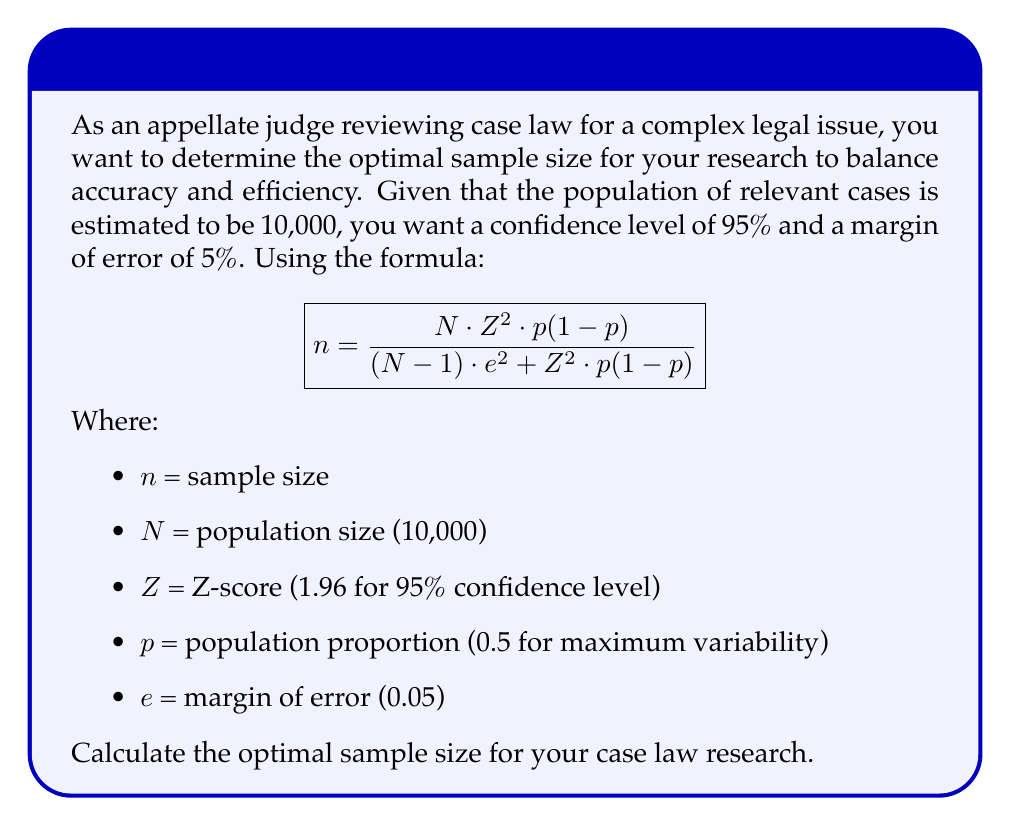What is the answer to this math problem? To solve this problem, we'll substitute the given values into the formula:

1) $N = 10,000$ (population size)
2) $Z = 1.96$ (Z-score for 95% confidence level)
3) $p = 0.5$ (assuming maximum variability)
4) $e = 0.05$ (5% margin of error)

Now, let's substitute these values into the formula:

$$n = \frac{10,000 \cdot 1.96^2 \cdot 0.5(1-0.5)}{(10,000-1) \cdot 0.05^2 + 1.96^2 \cdot 0.5(1-0.5)}$$

Simplify the numerator:
$$n = \frac{10,000 \cdot 3.8416 \cdot 0.25}{(9,999 \cdot 0.0025) + (3.8416 \cdot 0.25)}$$

$$n = \frac{9,604}{24.9975 + 0.9604}$$

$$n = \frac{9,604}{25.9579}$$

$$n = 369.98$$

Since we can't have a fractional sample size, we round up to the nearest whole number.
Answer: 370 cases 